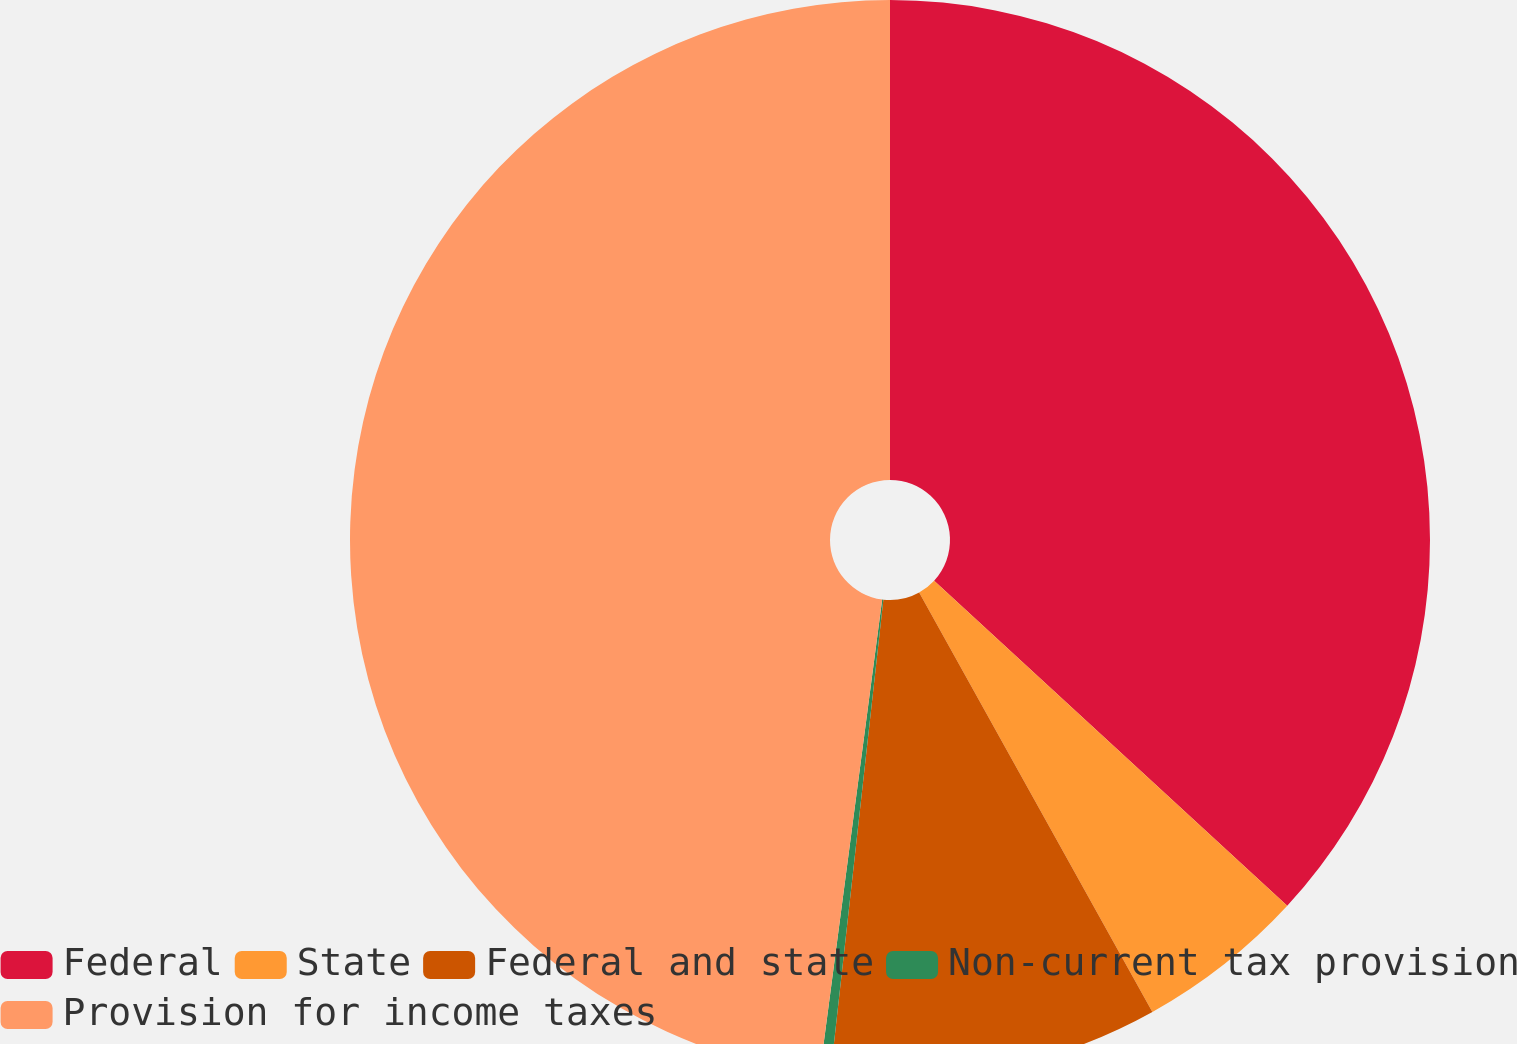Convert chart. <chart><loc_0><loc_0><loc_500><loc_500><pie_chart><fcel>Federal<fcel>State<fcel>Federal and state<fcel>Non-current tax provision<fcel>Provision for income taxes<nl><fcel>36.84%<fcel>5.08%<fcel>9.84%<fcel>0.32%<fcel>47.91%<nl></chart> 